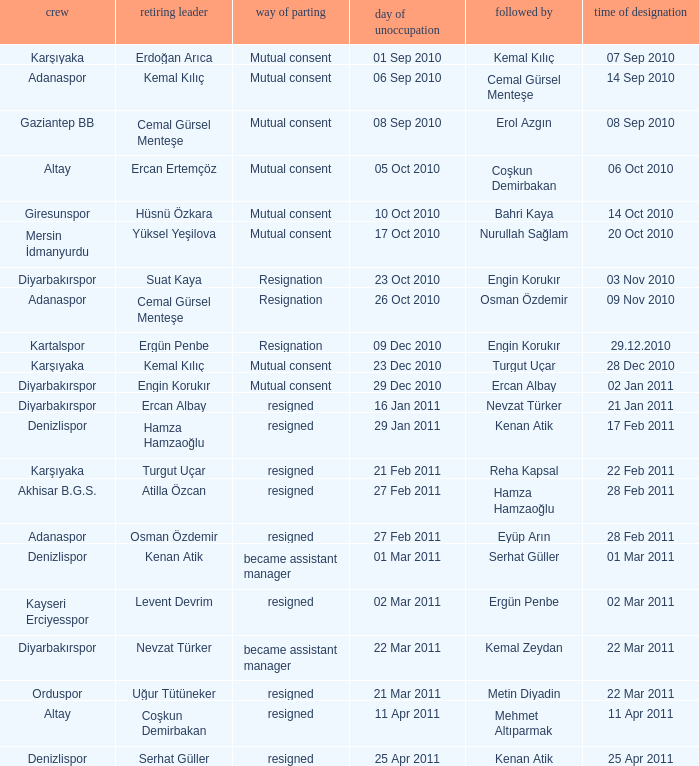Who replaced the manager of Akhisar B.G.S.? Hamza Hamzaoğlu. 